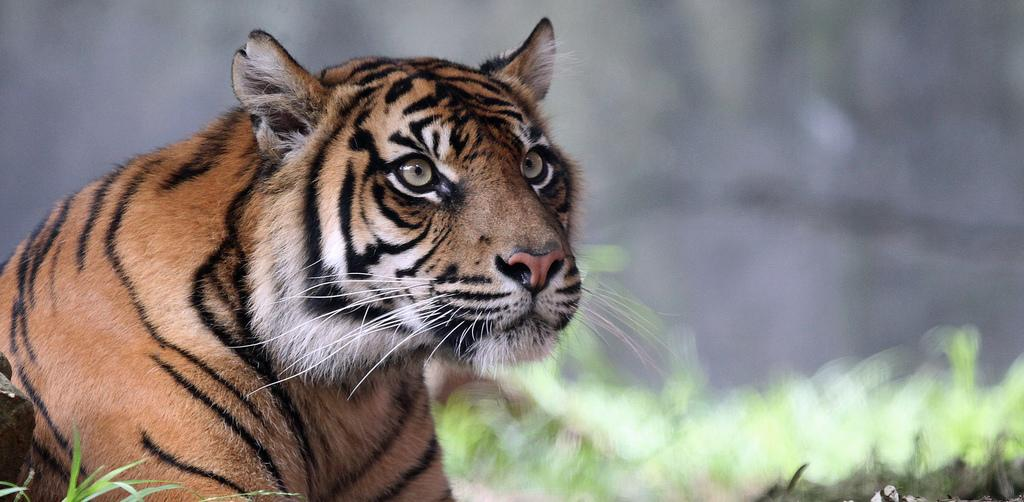What animal is in the image? There is a tiger in the image. What type of terrain is visible in the image? There is grass on the ground in the image. Can you describe the background of the image? The background of the image is completely blurred. What type of chess piece can be seen on the hill in the image? There is no hill, chess piece, or gate present in the image. 